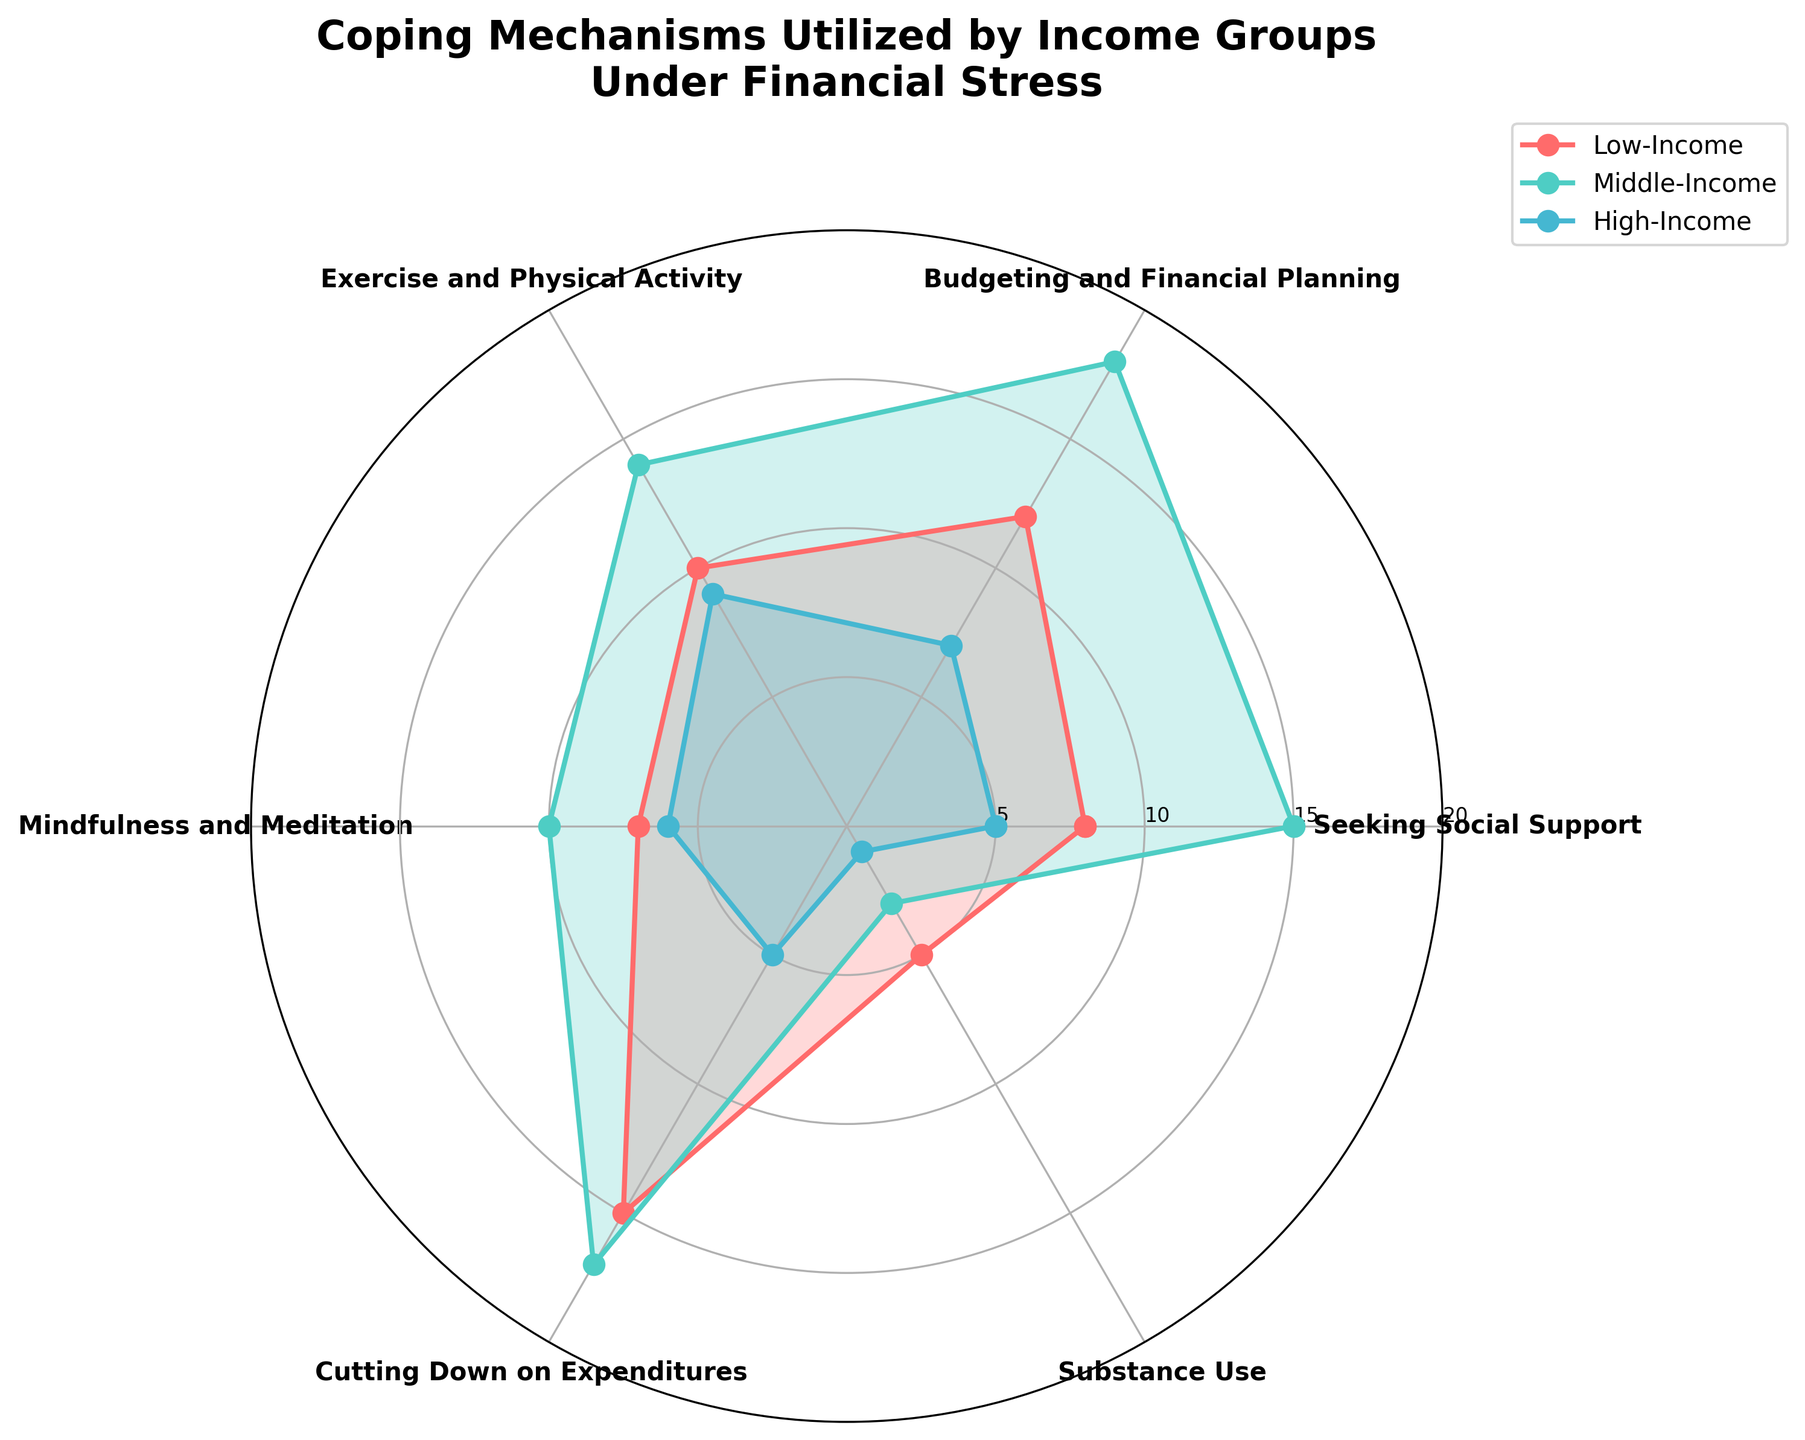What's the title of the radar chart? The title of the radar chart is found at the top of the figure. It summarizes what the chart is about.
Answer: "Coping Mechanisms Utilized by Income Groups Under Financial Stress" Which coping mechanism is the most frequently used among Low-Income groups? Look at the Low-Income group's plot on the radar chart and identify the coping mechanism that reaches the highest value.
Answer: Cutting Down on Expenditures Which income group utilizes Exercise and Physical Activity the most? Refer to the radar chart section on Exercise and Physical Activity and compare the values for Low-Income, Middle-Income, and High-Income groups.
Answer: Middle-Income How does the High-Income group's use of Seeking Social Support compare to the Low-Income group? Observe the radar chart for the Seeking Social Support category and compare the values between High-Income and Low-Income.
Answer: Less Which coping mechanism shows similar usage across all income groups? Identify the coping mechanisms by checking if the plotted lines for Low-Income, Middle-Income, and High-Income are closely positioned.
Answer: Mindfulness and Meditation Calculate the total frequency of the Budgeting and Financial Planning mechanism across all groups. Sum the values at the Budgeting and Financial Planning axis points across Low-Income, Middle-Income, and High-Income groups. 12 + 18 + 7 = 37
Answer: 37 What mechanism has the lowest frequency among all groups combined? Compare the total frequency sums for each coping mechanism across all income groups and identify the lowest one. Sum and compare values (Seeking Social Support 28, Budgeting and Financial Planning 37, Exercise and Physical Activity 33, Mindfulness and Meditation 23, Cutting Down on Expenditures 37, Substance Use 9).
Answer: Substance Use Which group shows wider variation in the utilization of different coping mechanisms? Evaluate the spread of values for each income group by looking at the variability of the points on the radar chart.
Answer: High-Income Which coping mechanism do all income groups use more frequently than Substance Use? Identify coping mechanisms where every group's value is higher than Substance Use's highest value (5). Analyze each mechanism.
Answer: Seeking Social Support, Budgeting and Financial Planning, Exercise and Physical Activity, Cutting Down on Expenditures 